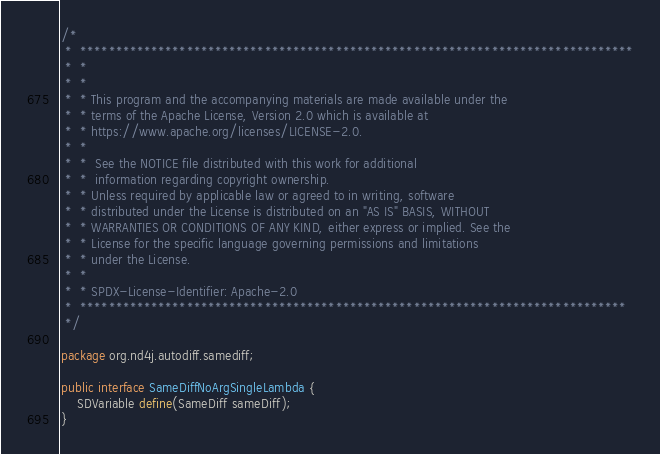Convert code to text. <code><loc_0><loc_0><loc_500><loc_500><_Java_>/*
 *  ******************************************************************************
 *  *
 *  *
 *  * This program and the accompanying materials are made available under the
 *  * terms of the Apache License, Version 2.0 which is available at
 *  * https://www.apache.org/licenses/LICENSE-2.0.
 *  *
 *  *  See the NOTICE file distributed with this work for additional
 *  *  information regarding copyright ownership.
 *  * Unless required by applicable law or agreed to in writing, software
 *  * distributed under the License is distributed on an "AS IS" BASIS, WITHOUT
 *  * WARRANTIES OR CONDITIONS OF ANY KIND, either express or implied. See the
 *  * License for the specific language governing permissions and limitations
 *  * under the License.
 *  *
 *  * SPDX-License-Identifier: Apache-2.0
 *  *****************************************************************************
 */

package org.nd4j.autodiff.samediff;

public interface SameDiffNoArgSingleLambda {
    SDVariable define(SameDiff sameDiff);
}
</code> 